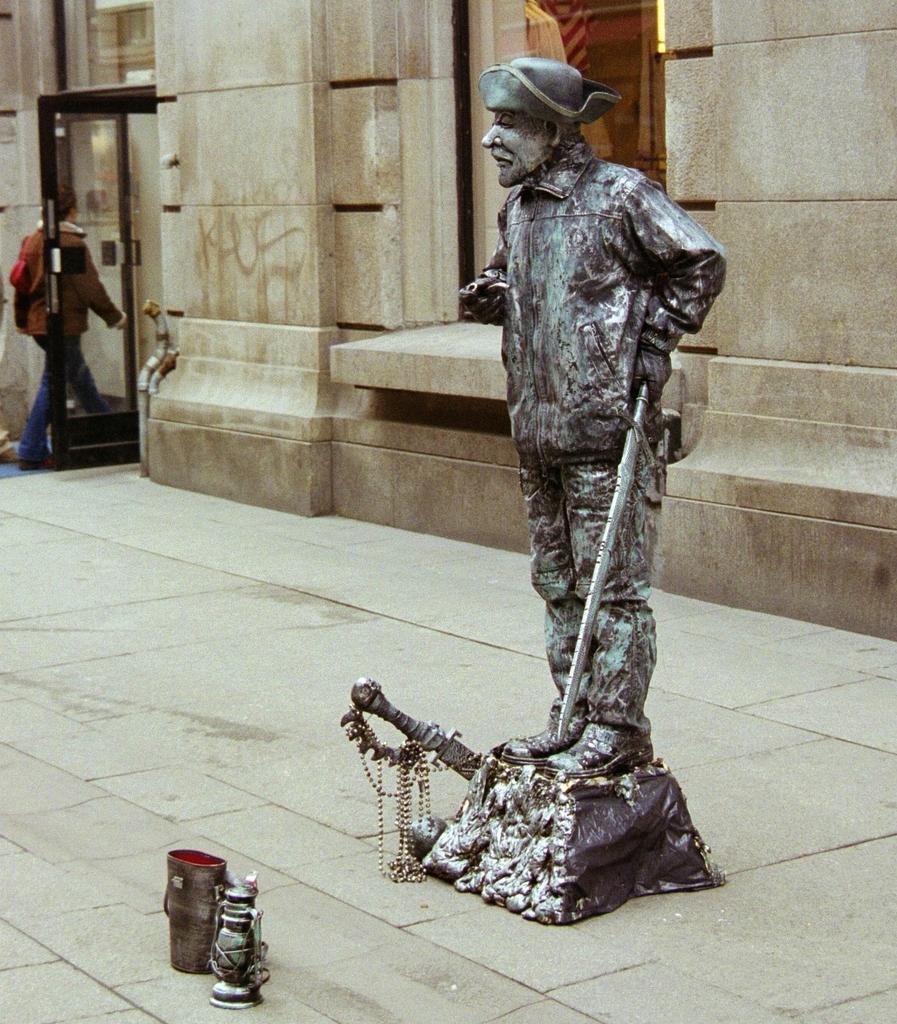Please provide a concise description of this image. In this picture I can see a building and a man walking and I can see a statue and couple of articles on the sidewalk. 